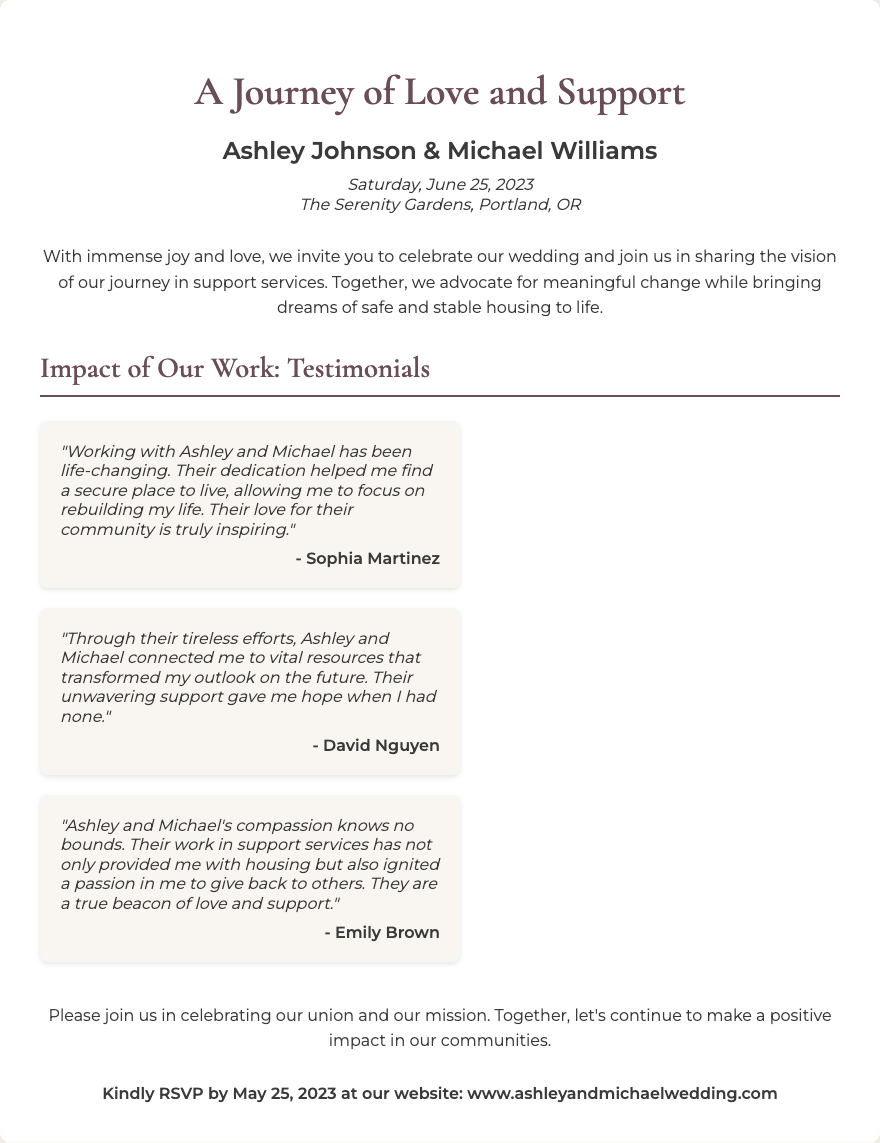What are the names of the couple? The invitation includes a section where both names are displayed prominently, identifying the couple getting married.
Answer: Ashley Johnson & Michael Williams What is the date of the wedding? The date of the event is mentioned in the date-location section of the invitation, indicating when the celebration will occur.
Answer: Saturday, June 25, 2023 Where is the wedding taking place? The location is stated in the same section as the date, providing information about the venue of the ceremony.
Answer: The Serenity Gardens, Portland, OR Who is the first testimonial from? The testimonials section lists names of individuals who have been positively impacted by the couple’s work, with Sophia being the first.
Answer: Sophia Martinez What type of support do Ashley and Michael provide? In the introduction, the couple mentions their role in advocating for change, specifically mentioning the type of support they focus on.
Answer: Support services How can guests RSVP? The RSVP instructions are provided at the end of the invitation, specifying how guests should confirm their attendance at the wedding.
Answer: Through their website What is mentioned about the couple's community involvement? The introduction highlights their commitment to making a positive impact in their community through their work in support services.
Answer: A positive impact What did Michael and Ashley inspire in Emily Brown? The testimonial from Emily Brown reflects the effect of Ashley and Michael's work on her, specifically mentioning a change in her perspective.
Answer: A passion to give back What is the website for RSVP? A clear instruction is given at the end of the document with the website guests should visit for RSVP.
Answer: www.ashleyandmichaelwedding.com 